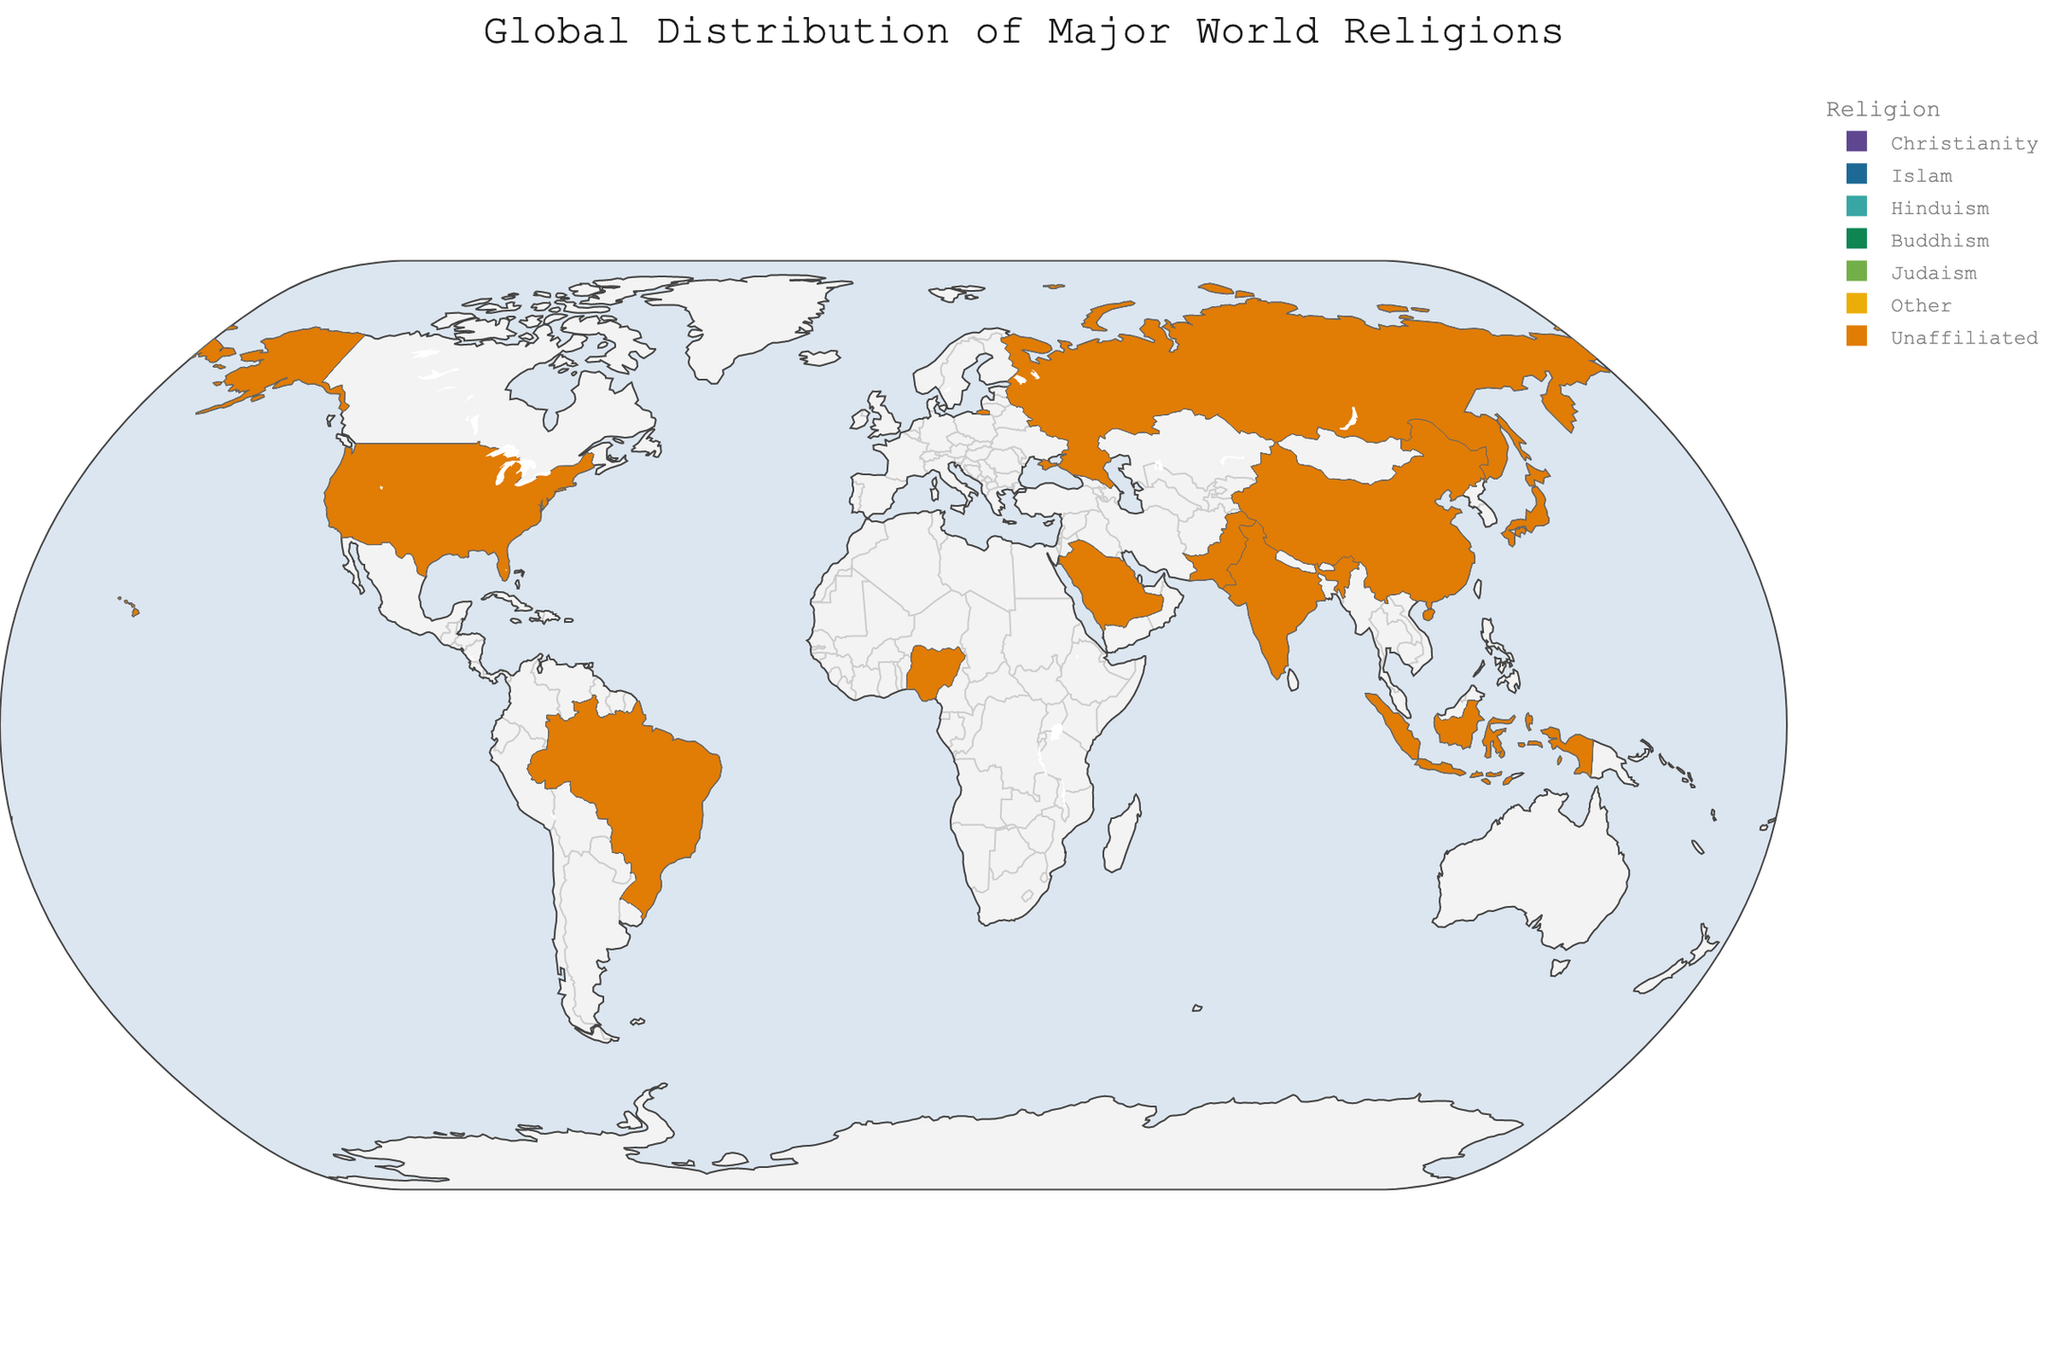What's the most predominant religion in Brazil? To determine the predominant religion in Brazil, look at the religion with the highest percentage in Brazil on the plot. Christianity has 88.0%, which is higher than any other religion in the country.
Answer: Christianity Which country has the highest percentage of Hindus? To find the country with the highest percentage of Hindus, look at the percentages for Hinduism across all countries. India has the highest percentage with 79.8%.
Answer: India In which country is Buddhism most prevalent? To determine where Buddhism is most prevalent, compare the percentages of Buddhism in all countries. Japan has the highest percentage at 36.2%.
Answer: Japan How does the percentage of Christians in Nigeria compare to that in the United States? Compare the percentage values for Christianity in Nigeria and the United States. Nigeria has 49.3% Christians, while the United States has 65.0%. Thus, the United States has a higher percentage of Christians.
Answer: The United States has a higher percentage What is the sum of the percentages of unaffiliated people in China and Japan? Calculate the sum of the unaffiliated percentages in China and Japan by adding 53.0% and 5.0%. \( 53 + 5 = 58 \).
Answer: 58% Which country has the least religious diversity in terms of major religions listed? To find the least religiously diverse country, observe the distribution of percentages. Saudi Arabia has the least diversity as 93.0% of its population follows Islam, and only small percentages follow other religions or are unaffiliated.
Answer: Saudi Arabia Compare the percentage of Muslims in Indonesia and Pakistan. Which country has a higher percentage? Look at the percentages for Islam in Indonesia and Pakistan. Indonesia has 87.2% Muslims, whereas Pakistan has 96.4%, making Pakistan the country with a higher percentage of Muslims.
Answer: Pakistan What is the percentage difference between Hindus in India and the United States? Subtract the percentage of Hindus in the United States (0.7%) from that in India (79.8%). \( 79.8 - 0.7 = 79.1 \).
Answer: 79.1% Which country has the smallest percentage of Christians? Find the smallest percentage under Christianity for all countries. Pakistan has the smallest percentage with 1.6%.
Answer: Pakistan What is the average percentage of Jews across all ten countries listed? Add the Jewish percentages for all countries (1.9 + 0 + 0 + 0.1 + 0 + 0 + 0 + 0.3 + 0 + 0) and divide by the number of countries (10). The sum is 2.3, so the average is \( \frac{2.3}{10} = 0.23 \).
Answer: 0.23% 